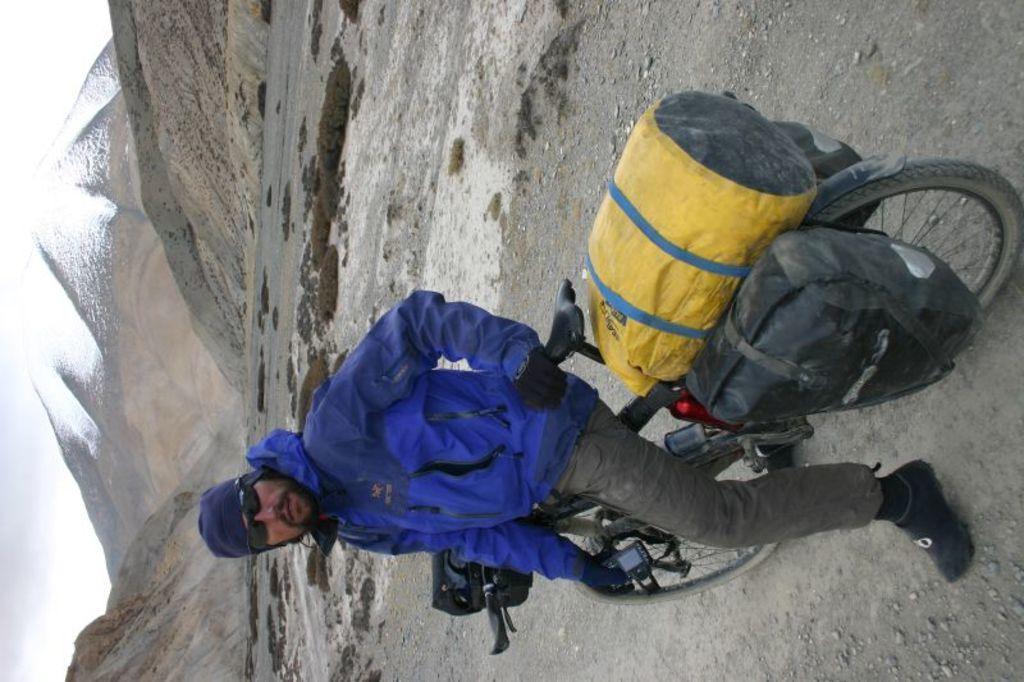Could you give a brief overview of what you see in this image? In the middle of the image a man is sitting on a bicycle. Behind him there are some hills. In the bottom left side of the image there is sky. 